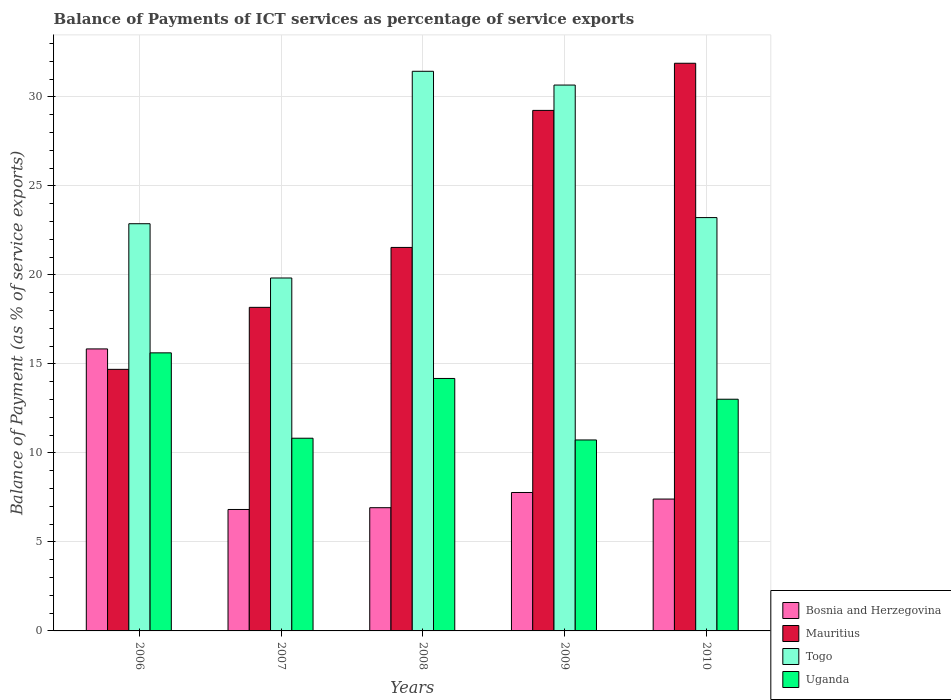How many groups of bars are there?
Make the answer very short. 5. Are the number of bars per tick equal to the number of legend labels?
Make the answer very short. Yes. How many bars are there on the 2nd tick from the left?
Keep it short and to the point. 4. How many bars are there on the 3rd tick from the right?
Offer a very short reply. 4. What is the balance of payments of ICT services in Togo in 2008?
Provide a short and direct response. 31.43. Across all years, what is the maximum balance of payments of ICT services in Bosnia and Herzegovina?
Provide a short and direct response. 15.84. Across all years, what is the minimum balance of payments of ICT services in Mauritius?
Provide a short and direct response. 14.69. In which year was the balance of payments of ICT services in Uganda minimum?
Keep it short and to the point. 2009. What is the total balance of payments of ICT services in Uganda in the graph?
Give a very brief answer. 64.36. What is the difference between the balance of payments of ICT services in Bosnia and Herzegovina in 2007 and that in 2008?
Make the answer very short. -0.1. What is the difference between the balance of payments of ICT services in Uganda in 2010 and the balance of payments of ICT services in Bosnia and Herzegovina in 2009?
Keep it short and to the point. 5.24. What is the average balance of payments of ICT services in Bosnia and Herzegovina per year?
Offer a very short reply. 8.95. In the year 2008, what is the difference between the balance of payments of ICT services in Mauritius and balance of payments of ICT services in Bosnia and Herzegovina?
Your answer should be very brief. 14.62. In how many years, is the balance of payments of ICT services in Bosnia and Herzegovina greater than 18 %?
Your answer should be compact. 0. What is the ratio of the balance of payments of ICT services in Mauritius in 2007 to that in 2008?
Provide a short and direct response. 0.84. Is the difference between the balance of payments of ICT services in Mauritius in 2008 and 2009 greater than the difference between the balance of payments of ICT services in Bosnia and Herzegovina in 2008 and 2009?
Keep it short and to the point. No. What is the difference between the highest and the second highest balance of payments of ICT services in Mauritius?
Your answer should be compact. 2.65. What is the difference between the highest and the lowest balance of payments of ICT services in Mauritius?
Your answer should be very brief. 17.19. In how many years, is the balance of payments of ICT services in Uganda greater than the average balance of payments of ICT services in Uganda taken over all years?
Offer a terse response. 3. Is the sum of the balance of payments of ICT services in Mauritius in 2008 and 2010 greater than the maximum balance of payments of ICT services in Bosnia and Herzegovina across all years?
Make the answer very short. Yes. Is it the case that in every year, the sum of the balance of payments of ICT services in Mauritius and balance of payments of ICT services in Uganda is greater than the sum of balance of payments of ICT services in Bosnia and Herzegovina and balance of payments of ICT services in Togo?
Give a very brief answer. Yes. What does the 3rd bar from the left in 2009 represents?
Your answer should be compact. Togo. What does the 2nd bar from the right in 2009 represents?
Provide a succinct answer. Togo. Is it the case that in every year, the sum of the balance of payments of ICT services in Uganda and balance of payments of ICT services in Togo is greater than the balance of payments of ICT services in Mauritius?
Make the answer very short. Yes. Are all the bars in the graph horizontal?
Keep it short and to the point. No. Does the graph contain grids?
Offer a terse response. Yes. How many legend labels are there?
Keep it short and to the point. 4. How are the legend labels stacked?
Provide a succinct answer. Vertical. What is the title of the graph?
Provide a short and direct response. Balance of Payments of ICT services as percentage of service exports. What is the label or title of the X-axis?
Provide a succinct answer. Years. What is the label or title of the Y-axis?
Your answer should be very brief. Balance of Payment (as % of service exports). What is the Balance of Payment (as % of service exports) of Bosnia and Herzegovina in 2006?
Provide a short and direct response. 15.84. What is the Balance of Payment (as % of service exports) in Mauritius in 2006?
Make the answer very short. 14.69. What is the Balance of Payment (as % of service exports) of Togo in 2006?
Your answer should be compact. 22.87. What is the Balance of Payment (as % of service exports) of Uganda in 2006?
Make the answer very short. 15.62. What is the Balance of Payment (as % of service exports) of Bosnia and Herzegovina in 2007?
Ensure brevity in your answer.  6.82. What is the Balance of Payment (as % of service exports) of Mauritius in 2007?
Provide a succinct answer. 18.17. What is the Balance of Payment (as % of service exports) in Togo in 2007?
Offer a very short reply. 19.82. What is the Balance of Payment (as % of service exports) of Uganda in 2007?
Offer a terse response. 10.82. What is the Balance of Payment (as % of service exports) of Bosnia and Herzegovina in 2008?
Give a very brief answer. 6.92. What is the Balance of Payment (as % of service exports) in Mauritius in 2008?
Offer a very short reply. 21.54. What is the Balance of Payment (as % of service exports) in Togo in 2008?
Give a very brief answer. 31.43. What is the Balance of Payment (as % of service exports) in Uganda in 2008?
Ensure brevity in your answer.  14.18. What is the Balance of Payment (as % of service exports) in Bosnia and Herzegovina in 2009?
Offer a very short reply. 7.78. What is the Balance of Payment (as % of service exports) of Mauritius in 2009?
Provide a succinct answer. 29.24. What is the Balance of Payment (as % of service exports) of Togo in 2009?
Make the answer very short. 30.66. What is the Balance of Payment (as % of service exports) of Uganda in 2009?
Ensure brevity in your answer.  10.73. What is the Balance of Payment (as % of service exports) in Bosnia and Herzegovina in 2010?
Provide a succinct answer. 7.41. What is the Balance of Payment (as % of service exports) in Mauritius in 2010?
Ensure brevity in your answer.  31.88. What is the Balance of Payment (as % of service exports) of Togo in 2010?
Offer a very short reply. 23.22. What is the Balance of Payment (as % of service exports) of Uganda in 2010?
Your answer should be compact. 13.01. Across all years, what is the maximum Balance of Payment (as % of service exports) in Bosnia and Herzegovina?
Your answer should be compact. 15.84. Across all years, what is the maximum Balance of Payment (as % of service exports) of Mauritius?
Make the answer very short. 31.88. Across all years, what is the maximum Balance of Payment (as % of service exports) of Togo?
Your answer should be compact. 31.43. Across all years, what is the maximum Balance of Payment (as % of service exports) of Uganda?
Your answer should be compact. 15.62. Across all years, what is the minimum Balance of Payment (as % of service exports) of Bosnia and Herzegovina?
Provide a short and direct response. 6.82. Across all years, what is the minimum Balance of Payment (as % of service exports) of Mauritius?
Make the answer very short. 14.69. Across all years, what is the minimum Balance of Payment (as % of service exports) of Togo?
Offer a terse response. 19.82. Across all years, what is the minimum Balance of Payment (as % of service exports) in Uganda?
Provide a succinct answer. 10.73. What is the total Balance of Payment (as % of service exports) in Bosnia and Herzegovina in the graph?
Offer a very short reply. 44.76. What is the total Balance of Payment (as % of service exports) in Mauritius in the graph?
Keep it short and to the point. 115.53. What is the total Balance of Payment (as % of service exports) in Togo in the graph?
Give a very brief answer. 128. What is the total Balance of Payment (as % of service exports) of Uganda in the graph?
Offer a very short reply. 64.36. What is the difference between the Balance of Payment (as % of service exports) of Bosnia and Herzegovina in 2006 and that in 2007?
Offer a very short reply. 9.02. What is the difference between the Balance of Payment (as % of service exports) in Mauritius in 2006 and that in 2007?
Provide a short and direct response. -3.48. What is the difference between the Balance of Payment (as % of service exports) in Togo in 2006 and that in 2007?
Provide a short and direct response. 3.05. What is the difference between the Balance of Payment (as % of service exports) in Uganda in 2006 and that in 2007?
Ensure brevity in your answer.  4.8. What is the difference between the Balance of Payment (as % of service exports) in Bosnia and Herzegovina in 2006 and that in 2008?
Provide a succinct answer. 8.92. What is the difference between the Balance of Payment (as % of service exports) of Mauritius in 2006 and that in 2008?
Keep it short and to the point. -6.85. What is the difference between the Balance of Payment (as % of service exports) in Togo in 2006 and that in 2008?
Offer a terse response. -8.56. What is the difference between the Balance of Payment (as % of service exports) of Uganda in 2006 and that in 2008?
Your answer should be compact. 1.44. What is the difference between the Balance of Payment (as % of service exports) in Bosnia and Herzegovina in 2006 and that in 2009?
Provide a short and direct response. 8.06. What is the difference between the Balance of Payment (as % of service exports) of Mauritius in 2006 and that in 2009?
Make the answer very short. -14.54. What is the difference between the Balance of Payment (as % of service exports) of Togo in 2006 and that in 2009?
Give a very brief answer. -7.79. What is the difference between the Balance of Payment (as % of service exports) in Uganda in 2006 and that in 2009?
Provide a succinct answer. 4.89. What is the difference between the Balance of Payment (as % of service exports) of Bosnia and Herzegovina in 2006 and that in 2010?
Offer a terse response. 8.43. What is the difference between the Balance of Payment (as % of service exports) of Mauritius in 2006 and that in 2010?
Provide a short and direct response. -17.19. What is the difference between the Balance of Payment (as % of service exports) of Togo in 2006 and that in 2010?
Keep it short and to the point. -0.34. What is the difference between the Balance of Payment (as % of service exports) of Uganda in 2006 and that in 2010?
Your answer should be very brief. 2.61. What is the difference between the Balance of Payment (as % of service exports) in Bosnia and Herzegovina in 2007 and that in 2008?
Your answer should be very brief. -0.1. What is the difference between the Balance of Payment (as % of service exports) in Mauritius in 2007 and that in 2008?
Your answer should be compact. -3.37. What is the difference between the Balance of Payment (as % of service exports) of Togo in 2007 and that in 2008?
Your response must be concise. -11.61. What is the difference between the Balance of Payment (as % of service exports) of Uganda in 2007 and that in 2008?
Keep it short and to the point. -3.36. What is the difference between the Balance of Payment (as % of service exports) in Bosnia and Herzegovina in 2007 and that in 2009?
Your answer should be very brief. -0.95. What is the difference between the Balance of Payment (as % of service exports) of Mauritius in 2007 and that in 2009?
Your answer should be very brief. -11.06. What is the difference between the Balance of Payment (as % of service exports) of Togo in 2007 and that in 2009?
Provide a short and direct response. -10.84. What is the difference between the Balance of Payment (as % of service exports) in Uganda in 2007 and that in 2009?
Give a very brief answer. 0.1. What is the difference between the Balance of Payment (as % of service exports) in Bosnia and Herzegovina in 2007 and that in 2010?
Offer a very short reply. -0.58. What is the difference between the Balance of Payment (as % of service exports) in Mauritius in 2007 and that in 2010?
Keep it short and to the point. -13.71. What is the difference between the Balance of Payment (as % of service exports) of Togo in 2007 and that in 2010?
Offer a very short reply. -3.39. What is the difference between the Balance of Payment (as % of service exports) in Uganda in 2007 and that in 2010?
Ensure brevity in your answer.  -2.19. What is the difference between the Balance of Payment (as % of service exports) in Bosnia and Herzegovina in 2008 and that in 2009?
Offer a terse response. -0.85. What is the difference between the Balance of Payment (as % of service exports) of Mauritius in 2008 and that in 2009?
Ensure brevity in your answer.  -7.7. What is the difference between the Balance of Payment (as % of service exports) of Togo in 2008 and that in 2009?
Keep it short and to the point. 0.77. What is the difference between the Balance of Payment (as % of service exports) in Uganda in 2008 and that in 2009?
Give a very brief answer. 3.45. What is the difference between the Balance of Payment (as % of service exports) in Bosnia and Herzegovina in 2008 and that in 2010?
Your response must be concise. -0.49. What is the difference between the Balance of Payment (as % of service exports) of Mauritius in 2008 and that in 2010?
Ensure brevity in your answer.  -10.34. What is the difference between the Balance of Payment (as % of service exports) of Togo in 2008 and that in 2010?
Your answer should be compact. 8.22. What is the difference between the Balance of Payment (as % of service exports) in Bosnia and Herzegovina in 2009 and that in 2010?
Offer a very short reply. 0.37. What is the difference between the Balance of Payment (as % of service exports) in Mauritius in 2009 and that in 2010?
Offer a terse response. -2.65. What is the difference between the Balance of Payment (as % of service exports) in Togo in 2009 and that in 2010?
Give a very brief answer. 7.44. What is the difference between the Balance of Payment (as % of service exports) of Uganda in 2009 and that in 2010?
Offer a very short reply. -2.29. What is the difference between the Balance of Payment (as % of service exports) in Bosnia and Herzegovina in 2006 and the Balance of Payment (as % of service exports) in Mauritius in 2007?
Your answer should be compact. -2.33. What is the difference between the Balance of Payment (as % of service exports) of Bosnia and Herzegovina in 2006 and the Balance of Payment (as % of service exports) of Togo in 2007?
Offer a terse response. -3.98. What is the difference between the Balance of Payment (as % of service exports) in Bosnia and Herzegovina in 2006 and the Balance of Payment (as % of service exports) in Uganda in 2007?
Your response must be concise. 5.02. What is the difference between the Balance of Payment (as % of service exports) in Mauritius in 2006 and the Balance of Payment (as % of service exports) in Togo in 2007?
Give a very brief answer. -5.13. What is the difference between the Balance of Payment (as % of service exports) in Mauritius in 2006 and the Balance of Payment (as % of service exports) in Uganda in 2007?
Provide a short and direct response. 3.87. What is the difference between the Balance of Payment (as % of service exports) in Togo in 2006 and the Balance of Payment (as % of service exports) in Uganda in 2007?
Your answer should be compact. 12.05. What is the difference between the Balance of Payment (as % of service exports) in Bosnia and Herzegovina in 2006 and the Balance of Payment (as % of service exports) in Mauritius in 2008?
Ensure brevity in your answer.  -5.7. What is the difference between the Balance of Payment (as % of service exports) in Bosnia and Herzegovina in 2006 and the Balance of Payment (as % of service exports) in Togo in 2008?
Provide a short and direct response. -15.59. What is the difference between the Balance of Payment (as % of service exports) in Bosnia and Herzegovina in 2006 and the Balance of Payment (as % of service exports) in Uganda in 2008?
Your answer should be very brief. 1.66. What is the difference between the Balance of Payment (as % of service exports) of Mauritius in 2006 and the Balance of Payment (as % of service exports) of Togo in 2008?
Provide a succinct answer. -16.74. What is the difference between the Balance of Payment (as % of service exports) in Mauritius in 2006 and the Balance of Payment (as % of service exports) in Uganda in 2008?
Provide a succinct answer. 0.51. What is the difference between the Balance of Payment (as % of service exports) of Togo in 2006 and the Balance of Payment (as % of service exports) of Uganda in 2008?
Provide a short and direct response. 8.69. What is the difference between the Balance of Payment (as % of service exports) in Bosnia and Herzegovina in 2006 and the Balance of Payment (as % of service exports) in Mauritius in 2009?
Provide a short and direct response. -13.4. What is the difference between the Balance of Payment (as % of service exports) of Bosnia and Herzegovina in 2006 and the Balance of Payment (as % of service exports) of Togo in 2009?
Keep it short and to the point. -14.82. What is the difference between the Balance of Payment (as % of service exports) in Bosnia and Herzegovina in 2006 and the Balance of Payment (as % of service exports) in Uganda in 2009?
Provide a short and direct response. 5.11. What is the difference between the Balance of Payment (as % of service exports) of Mauritius in 2006 and the Balance of Payment (as % of service exports) of Togo in 2009?
Offer a very short reply. -15.97. What is the difference between the Balance of Payment (as % of service exports) of Mauritius in 2006 and the Balance of Payment (as % of service exports) of Uganda in 2009?
Your response must be concise. 3.97. What is the difference between the Balance of Payment (as % of service exports) of Togo in 2006 and the Balance of Payment (as % of service exports) of Uganda in 2009?
Keep it short and to the point. 12.15. What is the difference between the Balance of Payment (as % of service exports) in Bosnia and Herzegovina in 2006 and the Balance of Payment (as % of service exports) in Mauritius in 2010?
Your answer should be compact. -16.05. What is the difference between the Balance of Payment (as % of service exports) in Bosnia and Herzegovina in 2006 and the Balance of Payment (as % of service exports) in Togo in 2010?
Provide a succinct answer. -7.38. What is the difference between the Balance of Payment (as % of service exports) of Bosnia and Herzegovina in 2006 and the Balance of Payment (as % of service exports) of Uganda in 2010?
Give a very brief answer. 2.83. What is the difference between the Balance of Payment (as % of service exports) of Mauritius in 2006 and the Balance of Payment (as % of service exports) of Togo in 2010?
Your response must be concise. -8.52. What is the difference between the Balance of Payment (as % of service exports) of Mauritius in 2006 and the Balance of Payment (as % of service exports) of Uganda in 2010?
Offer a very short reply. 1.68. What is the difference between the Balance of Payment (as % of service exports) in Togo in 2006 and the Balance of Payment (as % of service exports) in Uganda in 2010?
Provide a short and direct response. 9.86. What is the difference between the Balance of Payment (as % of service exports) in Bosnia and Herzegovina in 2007 and the Balance of Payment (as % of service exports) in Mauritius in 2008?
Keep it short and to the point. -14.72. What is the difference between the Balance of Payment (as % of service exports) of Bosnia and Herzegovina in 2007 and the Balance of Payment (as % of service exports) of Togo in 2008?
Offer a terse response. -24.61. What is the difference between the Balance of Payment (as % of service exports) in Bosnia and Herzegovina in 2007 and the Balance of Payment (as % of service exports) in Uganda in 2008?
Make the answer very short. -7.36. What is the difference between the Balance of Payment (as % of service exports) of Mauritius in 2007 and the Balance of Payment (as % of service exports) of Togo in 2008?
Your response must be concise. -13.26. What is the difference between the Balance of Payment (as % of service exports) in Mauritius in 2007 and the Balance of Payment (as % of service exports) in Uganda in 2008?
Keep it short and to the point. 3.99. What is the difference between the Balance of Payment (as % of service exports) of Togo in 2007 and the Balance of Payment (as % of service exports) of Uganda in 2008?
Give a very brief answer. 5.64. What is the difference between the Balance of Payment (as % of service exports) in Bosnia and Herzegovina in 2007 and the Balance of Payment (as % of service exports) in Mauritius in 2009?
Offer a very short reply. -22.41. What is the difference between the Balance of Payment (as % of service exports) in Bosnia and Herzegovina in 2007 and the Balance of Payment (as % of service exports) in Togo in 2009?
Offer a terse response. -23.84. What is the difference between the Balance of Payment (as % of service exports) of Bosnia and Herzegovina in 2007 and the Balance of Payment (as % of service exports) of Uganda in 2009?
Your response must be concise. -3.9. What is the difference between the Balance of Payment (as % of service exports) of Mauritius in 2007 and the Balance of Payment (as % of service exports) of Togo in 2009?
Your answer should be compact. -12.49. What is the difference between the Balance of Payment (as % of service exports) in Mauritius in 2007 and the Balance of Payment (as % of service exports) in Uganda in 2009?
Make the answer very short. 7.45. What is the difference between the Balance of Payment (as % of service exports) in Togo in 2007 and the Balance of Payment (as % of service exports) in Uganda in 2009?
Your answer should be very brief. 9.1. What is the difference between the Balance of Payment (as % of service exports) in Bosnia and Herzegovina in 2007 and the Balance of Payment (as % of service exports) in Mauritius in 2010?
Keep it short and to the point. -25.06. What is the difference between the Balance of Payment (as % of service exports) of Bosnia and Herzegovina in 2007 and the Balance of Payment (as % of service exports) of Togo in 2010?
Give a very brief answer. -16.39. What is the difference between the Balance of Payment (as % of service exports) in Bosnia and Herzegovina in 2007 and the Balance of Payment (as % of service exports) in Uganda in 2010?
Your answer should be very brief. -6.19. What is the difference between the Balance of Payment (as % of service exports) of Mauritius in 2007 and the Balance of Payment (as % of service exports) of Togo in 2010?
Provide a short and direct response. -5.04. What is the difference between the Balance of Payment (as % of service exports) of Mauritius in 2007 and the Balance of Payment (as % of service exports) of Uganda in 2010?
Provide a short and direct response. 5.16. What is the difference between the Balance of Payment (as % of service exports) in Togo in 2007 and the Balance of Payment (as % of service exports) in Uganda in 2010?
Keep it short and to the point. 6.81. What is the difference between the Balance of Payment (as % of service exports) in Bosnia and Herzegovina in 2008 and the Balance of Payment (as % of service exports) in Mauritius in 2009?
Your answer should be compact. -22.32. What is the difference between the Balance of Payment (as % of service exports) of Bosnia and Herzegovina in 2008 and the Balance of Payment (as % of service exports) of Togo in 2009?
Your response must be concise. -23.74. What is the difference between the Balance of Payment (as % of service exports) in Bosnia and Herzegovina in 2008 and the Balance of Payment (as % of service exports) in Uganda in 2009?
Provide a succinct answer. -3.81. What is the difference between the Balance of Payment (as % of service exports) of Mauritius in 2008 and the Balance of Payment (as % of service exports) of Togo in 2009?
Make the answer very short. -9.12. What is the difference between the Balance of Payment (as % of service exports) in Mauritius in 2008 and the Balance of Payment (as % of service exports) in Uganda in 2009?
Provide a succinct answer. 10.81. What is the difference between the Balance of Payment (as % of service exports) of Togo in 2008 and the Balance of Payment (as % of service exports) of Uganda in 2009?
Provide a short and direct response. 20.71. What is the difference between the Balance of Payment (as % of service exports) of Bosnia and Herzegovina in 2008 and the Balance of Payment (as % of service exports) of Mauritius in 2010?
Your answer should be very brief. -24.96. What is the difference between the Balance of Payment (as % of service exports) in Bosnia and Herzegovina in 2008 and the Balance of Payment (as % of service exports) in Togo in 2010?
Your answer should be very brief. -16.3. What is the difference between the Balance of Payment (as % of service exports) in Bosnia and Herzegovina in 2008 and the Balance of Payment (as % of service exports) in Uganda in 2010?
Offer a terse response. -6.09. What is the difference between the Balance of Payment (as % of service exports) of Mauritius in 2008 and the Balance of Payment (as % of service exports) of Togo in 2010?
Provide a short and direct response. -1.68. What is the difference between the Balance of Payment (as % of service exports) in Mauritius in 2008 and the Balance of Payment (as % of service exports) in Uganda in 2010?
Give a very brief answer. 8.53. What is the difference between the Balance of Payment (as % of service exports) of Togo in 2008 and the Balance of Payment (as % of service exports) of Uganda in 2010?
Offer a very short reply. 18.42. What is the difference between the Balance of Payment (as % of service exports) of Bosnia and Herzegovina in 2009 and the Balance of Payment (as % of service exports) of Mauritius in 2010?
Offer a terse response. -24.11. What is the difference between the Balance of Payment (as % of service exports) of Bosnia and Herzegovina in 2009 and the Balance of Payment (as % of service exports) of Togo in 2010?
Your answer should be compact. -15.44. What is the difference between the Balance of Payment (as % of service exports) of Bosnia and Herzegovina in 2009 and the Balance of Payment (as % of service exports) of Uganda in 2010?
Offer a very short reply. -5.24. What is the difference between the Balance of Payment (as % of service exports) in Mauritius in 2009 and the Balance of Payment (as % of service exports) in Togo in 2010?
Offer a terse response. 6.02. What is the difference between the Balance of Payment (as % of service exports) of Mauritius in 2009 and the Balance of Payment (as % of service exports) of Uganda in 2010?
Provide a short and direct response. 16.22. What is the difference between the Balance of Payment (as % of service exports) of Togo in 2009 and the Balance of Payment (as % of service exports) of Uganda in 2010?
Your response must be concise. 17.65. What is the average Balance of Payment (as % of service exports) of Bosnia and Herzegovina per year?
Provide a short and direct response. 8.95. What is the average Balance of Payment (as % of service exports) of Mauritius per year?
Provide a succinct answer. 23.11. What is the average Balance of Payment (as % of service exports) in Togo per year?
Offer a terse response. 25.6. What is the average Balance of Payment (as % of service exports) of Uganda per year?
Provide a succinct answer. 12.87. In the year 2006, what is the difference between the Balance of Payment (as % of service exports) in Bosnia and Herzegovina and Balance of Payment (as % of service exports) in Mauritius?
Offer a terse response. 1.15. In the year 2006, what is the difference between the Balance of Payment (as % of service exports) in Bosnia and Herzegovina and Balance of Payment (as % of service exports) in Togo?
Give a very brief answer. -7.03. In the year 2006, what is the difference between the Balance of Payment (as % of service exports) in Bosnia and Herzegovina and Balance of Payment (as % of service exports) in Uganda?
Give a very brief answer. 0.22. In the year 2006, what is the difference between the Balance of Payment (as % of service exports) of Mauritius and Balance of Payment (as % of service exports) of Togo?
Make the answer very short. -8.18. In the year 2006, what is the difference between the Balance of Payment (as % of service exports) of Mauritius and Balance of Payment (as % of service exports) of Uganda?
Your answer should be very brief. -0.93. In the year 2006, what is the difference between the Balance of Payment (as % of service exports) of Togo and Balance of Payment (as % of service exports) of Uganda?
Your response must be concise. 7.25. In the year 2007, what is the difference between the Balance of Payment (as % of service exports) of Bosnia and Herzegovina and Balance of Payment (as % of service exports) of Mauritius?
Make the answer very short. -11.35. In the year 2007, what is the difference between the Balance of Payment (as % of service exports) of Bosnia and Herzegovina and Balance of Payment (as % of service exports) of Togo?
Your response must be concise. -13. In the year 2007, what is the difference between the Balance of Payment (as % of service exports) of Bosnia and Herzegovina and Balance of Payment (as % of service exports) of Uganda?
Provide a short and direct response. -4. In the year 2007, what is the difference between the Balance of Payment (as % of service exports) in Mauritius and Balance of Payment (as % of service exports) in Togo?
Offer a very short reply. -1.65. In the year 2007, what is the difference between the Balance of Payment (as % of service exports) in Mauritius and Balance of Payment (as % of service exports) in Uganda?
Give a very brief answer. 7.35. In the year 2007, what is the difference between the Balance of Payment (as % of service exports) of Togo and Balance of Payment (as % of service exports) of Uganda?
Provide a short and direct response. 9. In the year 2008, what is the difference between the Balance of Payment (as % of service exports) of Bosnia and Herzegovina and Balance of Payment (as % of service exports) of Mauritius?
Your answer should be compact. -14.62. In the year 2008, what is the difference between the Balance of Payment (as % of service exports) of Bosnia and Herzegovina and Balance of Payment (as % of service exports) of Togo?
Your answer should be very brief. -24.51. In the year 2008, what is the difference between the Balance of Payment (as % of service exports) of Bosnia and Herzegovina and Balance of Payment (as % of service exports) of Uganda?
Your answer should be very brief. -7.26. In the year 2008, what is the difference between the Balance of Payment (as % of service exports) in Mauritius and Balance of Payment (as % of service exports) in Togo?
Offer a terse response. -9.89. In the year 2008, what is the difference between the Balance of Payment (as % of service exports) of Mauritius and Balance of Payment (as % of service exports) of Uganda?
Offer a terse response. 7.36. In the year 2008, what is the difference between the Balance of Payment (as % of service exports) in Togo and Balance of Payment (as % of service exports) in Uganda?
Keep it short and to the point. 17.25. In the year 2009, what is the difference between the Balance of Payment (as % of service exports) in Bosnia and Herzegovina and Balance of Payment (as % of service exports) in Mauritius?
Provide a short and direct response. -21.46. In the year 2009, what is the difference between the Balance of Payment (as % of service exports) in Bosnia and Herzegovina and Balance of Payment (as % of service exports) in Togo?
Ensure brevity in your answer.  -22.89. In the year 2009, what is the difference between the Balance of Payment (as % of service exports) of Bosnia and Herzegovina and Balance of Payment (as % of service exports) of Uganda?
Ensure brevity in your answer.  -2.95. In the year 2009, what is the difference between the Balance of Payment (as % of service exports) in Mauritius and Balance of Payment (as % of service exports) in Togo?
Offer a very short reply. -1.42. In the year 2009, what is the difference between the Balance of Payment (as % of service exports) in Mauritius and Balance of Payment (as % of service exports) in Uganda?
Your answer should be very brief. 18.51. In the year 2009, what is the difference between the Balance of Payment (as % of service exports) of Togo and Balance of Payment (as % of service exports) of Uganda?
Give a very brief answer. 19.93. In the year 2010, what is the difference between the Balance of Payment (as % of service exports) in Bosnia and Herzegovina and Balance of Payment (as % of service exports) in Mauritius?
Your answer should be compact. -24.48. In the year 2010, what is the difference between the Balance of Payment (as % of service exports) of Bosnia and Herzegovina and Balance of Payment (as % of service exports) of Togo?
Offer a very short reply. -15.81. In the year 2010, what is the difference between the Balance of Payment (as % of service exports) in Bosnia and Herzegovina and Balance of Payment (as % of service exports) in Uganda?
Offer a terse response. -5.61. In the year 2010, what is the difference between the Balance of Payment (as % of service exports) of Mauritius and Balance of Payment (as % of service exports) of Togo?
Provide a short and direct response. 8.67. In the year 2010, what is the difference between the Balance of Payment (as % of service exports) in Mauritius and Balance of Payment (as % of service exports) in Uganda?
Give a very brief answer. 18.87. In the year 2010, what is the difference between the Balance of Payment (as % of service exports) of Togo and Balance of Payment (as % of service exports) of Uganda?
Provide a succinct answer. 10.2. What is the ratio of the Balance of Payment (as % of service exports) in Bosnia and Herzegovina in 2006 to that in 2007?
Keep it short and to the point. 2.32. What is the ratio of the Balance of Payment (as % of service exports) of Mauritius in 2006 to that in 2007?
Keep it short and to the point. 0.81. What is the ratio of the Balance of Payment (as % of service exports) in Togo in 2006 to that in 2007?
Your response must be concise. 1.15. What is the ratio of the Balance of Payment (as % of service exports) of Uganda in 2006 to that in 2007?
Provide a succinct answer. 1.44. What is the ratio of the Balance of Payment (as % of service exports) in Bosnia and Herzegovina in 2006 to that in 2008?
Give a very brief answer. 2.29. What is the ratio of the Balance of Payment (as % of service exports) in Mauritius in 2006 to that in 2008?
Provide a short and direct response. 0.68. What is the ratio of the Balance of Payment (as % of service exports) of Togo in 2006 to that in 2008?
Provide a short and direct response. 0.73. What is the ratio of the Balance of Payment (as % of service exports) of Uganda in 2006 to that in 2008?
Your answer should be compact. 1.1. What is the ratio of the Balance of Payment (as % of service exports) in Bosnia and Herzegovina in 2006 to that in 2009?
Your answer should be very brief. 2.04. What is the ratio of the Balance of Payment (as % of service exports) of Mauritius in 2006 to that in 2009?
Keep it short and to the point. 0.5. What is the ratio of the Balance of Payment (as % of service exports) of Togo in 2006 to that in 2009?
Offer a terse response. 0.75. What is the ratio of the Balance of Payment (as % of service exports) of Uganda in 2006 to that in 2009?
Ensure brevity in your answer.  1.46. What is the ratio of the Balance of Payment (as % of service exports) of Bosnia and Herzegovina in 2006 to that in 2010?
Ensure brevity in your answer.  2.14. What is the ratio of the Balance of Payment (as % of service exports) in Mauritius in 2006 to that in 2010?
Your answer should be very brief. 0.46. What is the ratio of the Balance of Payment (as % of service exports) of Togo in 2006 to that in 2010?
Give a very brief answer. 0.99. What is the ratio of the Balance of Payment (as % of service exports) in Uganda in 2006 to that in 2010?
Ensure brevity in your answer.  1.2. What is the ratio of the Balance of Payment (as % of service exports) of Bosnia and Herzegovina in 2007 to that in 2008?
Give a very brief answer. 0.99. What is the ratio of the Balance of Payment (as % of service exports) in Mauritius in 2007 to that in 2008?
Give a very brief answer. 0.84. What is the ratio of the Balance of Payment (as % of service exports) in Togo in 2007 to that in 2008?
Ensure brevity in your answer.  0.63. What is the ratio of the Balance of Payment (as % of service exports) in Uganda in 2007 to that in 2008?
Give a very brief answer. 0.76. What is the ratio of the Balance of Payment (as % of service exports) in Bosnia and Herzegovina in 2007 to that in 2009?
Give a very brief answer. 0.88. What is the ratio of the Balance of Payment (as % of service exports) of Mauritius in 2007 to that in 2009?
Provide a succinct answer. 0.62. What is the ratio of the Balance of Payment (as % of service exports) of Togo in 2007 to that in 2009?
Your answer should be compact. 0.65. What is the ratio of the Balance of Payment (as % of service exports) in Uganda in 2007 to that in 2009?
Your answer should be very brief. 1.01. What is the ratio of the Balance of Payment (as % of service exports) in Bosnia and Herzegovina in 2007 to that in 2010?
Offer a terse response. 0.92. What is the ratio of the Balance of Payment (as % of service exports) in Mauritius in 2007 to that in 2010?
Your response must be concise. 0.57. What is the ratio of the Balance of Payment (as % of service exports) of Togo in 2007 to that in 2010?
Provide a short and direct response. 0.85. What is the ratio of the Balance of Payment (as % of service exports) in Uganda in 2007 to that in 2010?
Your response must be concise. 0.83. What is the ratio of the Balance of Payment (as % of service exports) in Bosnia and Herzegovina in 2008 to that in 2009?
Ensure brevity in your answer.  0.89. What is the ratio of the Balance of Payment (as % of service exports) in Mauritius in 2008 to that in 2009?
Give a very brief answer. 0.74. What is the ratio of the Balance of Payment (as % of service exports) of Togo in 2008 to that in 2009?
Keep it short and to the point. 1.03. What is the ratio of the Balance of Payment (as % of service exports) in Uganda in 2008 to that in 2009?
Keep it short and to the point. 1.32. What is the ratio of the Balance of Payment (as % of service exports) of Bosnia and Herzegovina in 2008 to that in 2010?
Provide a short and direct response. 0.93. What is the ratio of the Balance of Payment (as % of service exports) of Mauritius in 2008 to that in 2010?
Give a very brief answer. 0.68. What is the ratio of the Balance of Payment (as % of service exports) in Togo in 2008 to that in 2010?
Give a very brief answer. 1.35. What is the ratio of the Balance of Payment (as % of service exports) of Uganda in 2008 to that in 2010?
Offer a very short reply. 1.09. What is the ratio of the Balance of Payment (as % of service exports) in Bosnia and Herzegovina in 2009 to that in 2010?
Provide a short and direct response. 1.05. What is the ratio of the Balance of Payment (as % of service exports) in Mauritius in 2009 to that in 2010?
Make the answer very short. 0.92. What is the ratio of the Balance of Payment (as % of service exports) of Togo in 2009 to that in 2010?
Offer a very short reply. 1.32. What is the ratio of the Balance of Payment (as % of service exports) of Uganda in 2009 to that in 2010?
Provide a succinct answer. 0.82. What is the difference between the highest and the second highest Balance of Payment (as % of service exports) of Bosnia and Herzegovina?
Keep it short and to the point. 8.06. What is the difference between the highest and the second highest Balance of Payment (as % of service exports) of Mauritius?
Offer a terse response. 2.65. What is the difference between the highest and the second highest Balance of Payment (as % of service exports) in Togo?
Your answer should be compact. 0.77. What is the difference between the highest and the second highest Balance of Payment (as % of service exports) in Uganda?
Your answer should be compact. 1.44. What is the difference between the highest and the lowest Balance of Payment (as % of service exports) of Bosnia and Herzegovina?
Keep it short and to the point. 9.02. What is the difference between the highest and the lowest Balance of Payment (as % of service exports) in Mauritius?
Your response must be concise. 17.19. What is the difference between the highest and the lowest Balance of Payment (as % of service exports) in Togo?
Your answer should be very brief. 11.61. What is the difference between the highest and the lowest Balance of Payment (as % of service exports) in Uganda?
Offer a terse response. 4.89. 